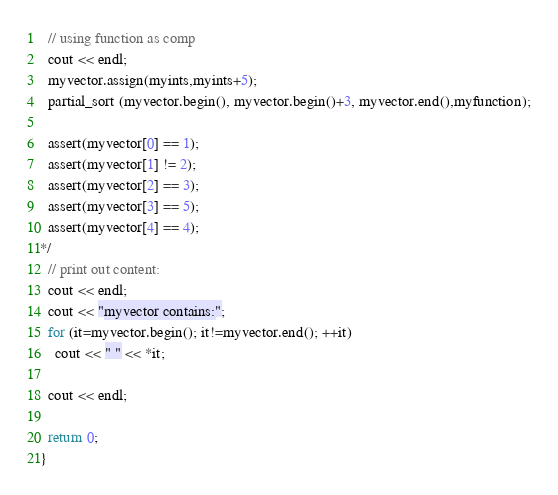<code> <loc_0><loc_0><loc_500><loc_500><_C++_>  // using function as comp
  cout << endl;
  myvector.assign(myints,myints+5);
  partial_sort (myvector.begin(), myvector.begin()+3, myvector.end(),myfunction);

  assert(myvector[0] == 1);
  assert(myvector[1] != 2);
  assert(myvector[2] == 3);
  assert(myvector[3] == 5);
  assert(myvector[4] == 4);
*/
  // print out content:
  cout << endl;
  cout << "myvector contains:";
  for (it=myvector.begin(); it!=myvector.end(); ++it)
    cout << " " << *it;

  cout << endl;

  return 0;
}
</code> 